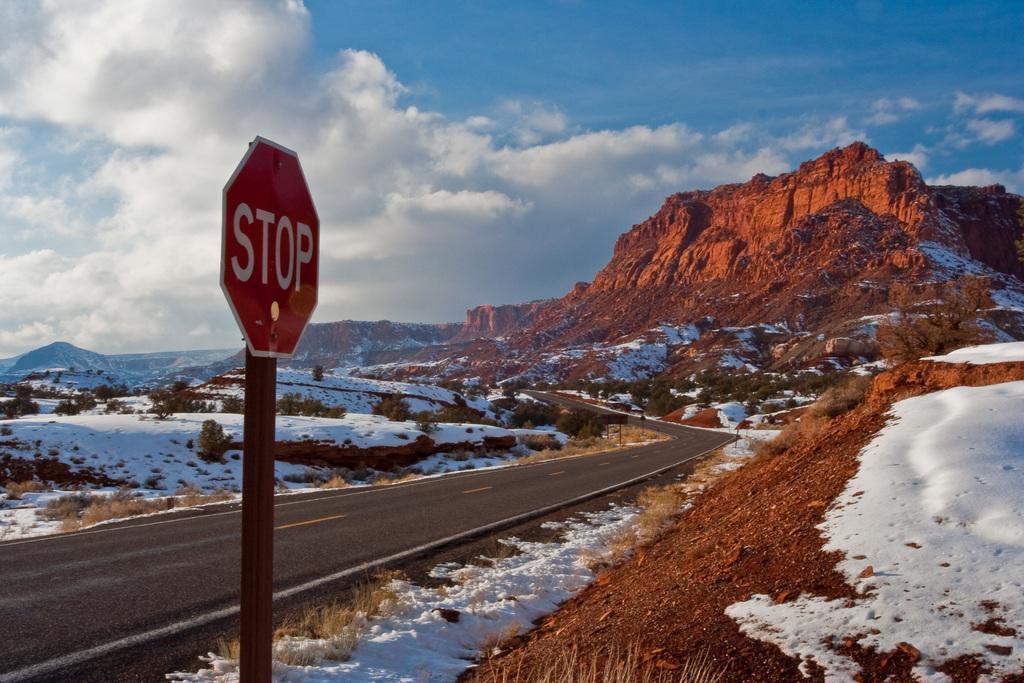How would you summarize this image in a sentence or two? In the center of the image there is a road. Beside the road there is a sign board. At the bottom of the image there is snow on the surface. In the background of the image there are plants, mountains and sky. 